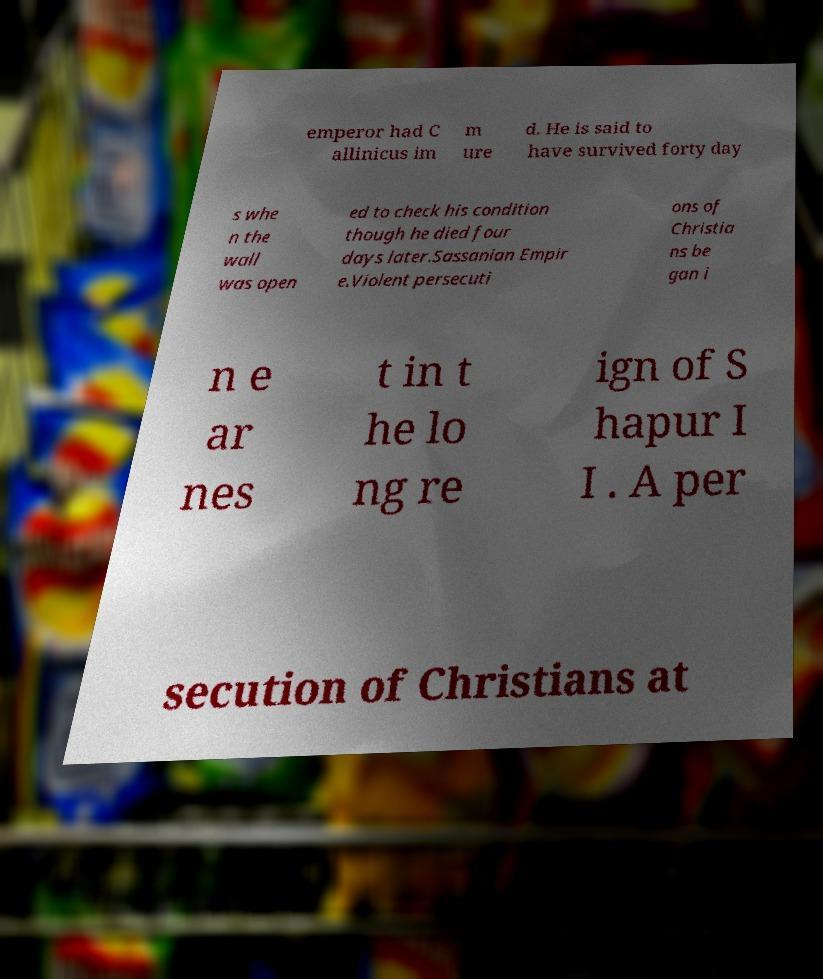Could you extract and type out the text from this image? emperor had C allinicus im m ure d. He is said to have survived forty day s whe n the wall was open ed to check his condition though he died four days later.Sassanian Empir e.Violent persecuti ons of Christia ns be gan i n e ar nes t in t he lo ng re ign of S hapur I I . A per secution of Christians at 